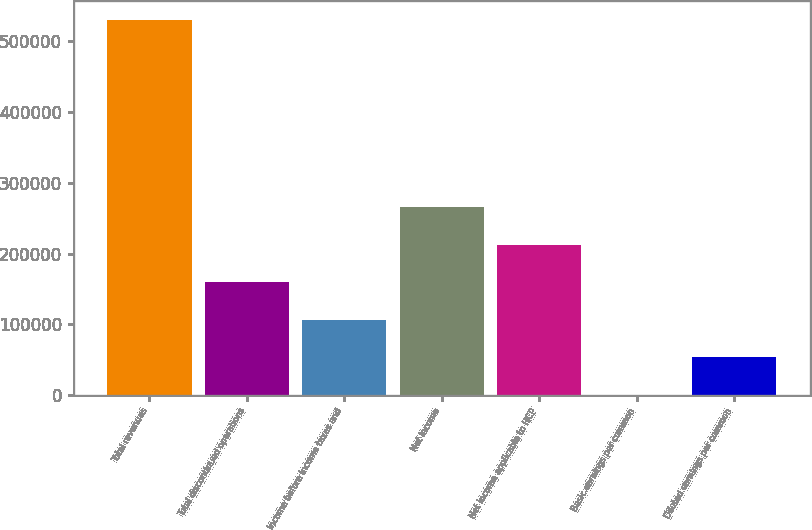Convert chart to OTSL. <chart><loc_0><loc_0><loc_500><loc_500><bar_chart><fcel>Total revenues<fcel>Total discontinued operations<fcel>Income before income taxes and<fcel>Net income<fcel>Net income applicable to HCP<fcel>Basic earnings per common<fcel>Diluted earnings per common<nl><fcel>530555<fcel>159167<fcel>106111<fcel>265278<fcel>212222<fcel>0.32<fcel>53055.8<nl></chart> 